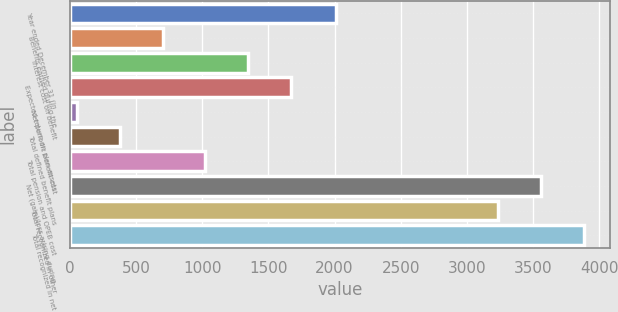Convert chart to OTSL. <chart><loc_0><loc_0><loc_500><loc_500><bar_chart><fcel>Year ended December 31 (in<fcel>Benefits earned during the<fcel>Interest cost on benefit<fcel>Expected return on plan assets<fcel>Net periodic benefit cost<fcel>Total defined benefit plans<fcel>Total pension and OPEB cost<fcel>Net (gain)/loss arising during<fcel>Total recognized in other<fcel>Total recognized in net<nl><fcel>2008<fcel>699.6<fcel>1347.2<fcel>1671<fcel>52<fcel>375.8<fcel>1023.4<fcel>3561.8<fcel>3238<fcel>3885.6<nl></chart> 